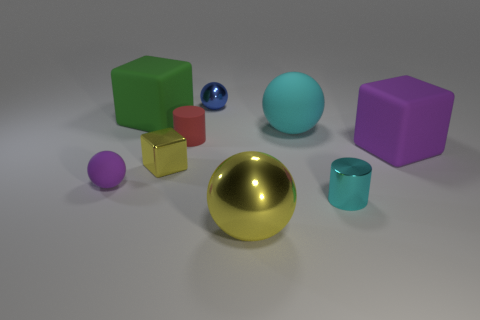Add 1 small cyan cylinders. How many objects exist? 10 Subtract all yellow blocks. How many blocks are left? 2 Subtract all shiny blocks. How many blocks are left? 2 Subtract all cylinders. How many objects are left? 7 Subtract 2 cylinders. How many cylinders are left? 0 Subtract all cyan blocks. Subtract all gray cylinders. How many blocks are left? 3 Subtract all brown balls. How many cyan cubes are left? 0 Subtract all small cyan metallic objects. Subtract all small blue spheres. How many objects are left? 7 Add 5 tiny red cylinders. How many tiny red cylinders are left? 6 Add 4 small red cylinders. How many small red cylinders exist? 5 